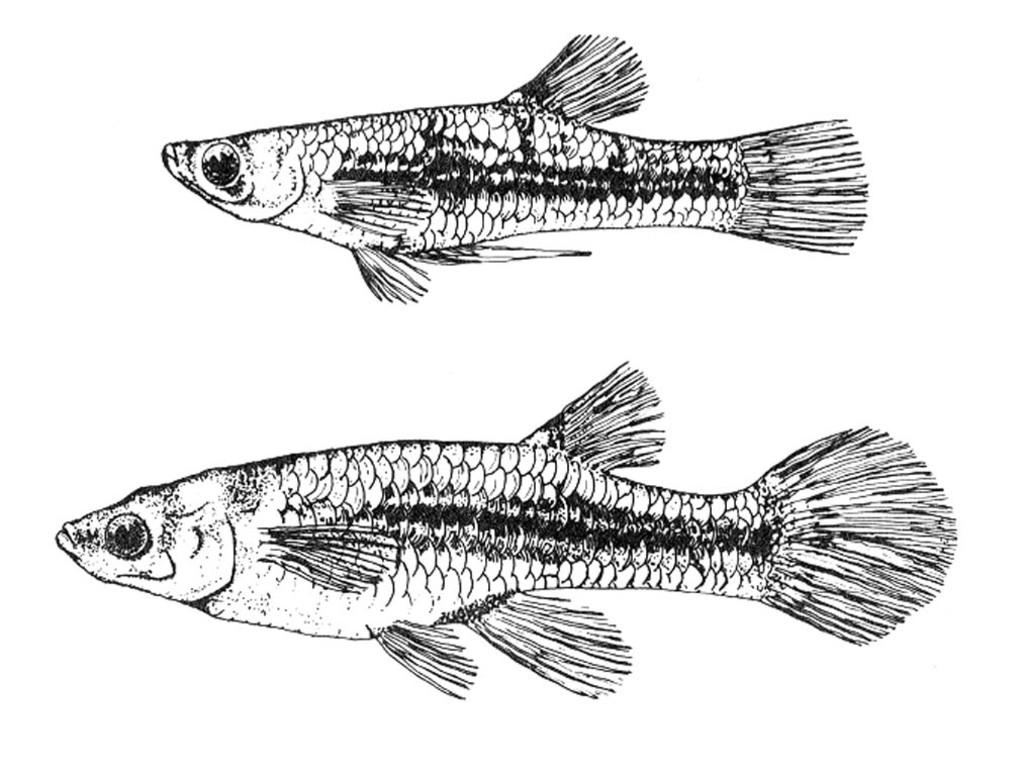What is the main subject of the image? The main subject of the image is a sketch of fishes. Can you describe the sketch in more detail? Unfortunately, the facts provided do not give any additional details about the sketch. What type of flower is depicted in the library in the image? There is no flower or library present in the image; it contains a sketch of fishes. 